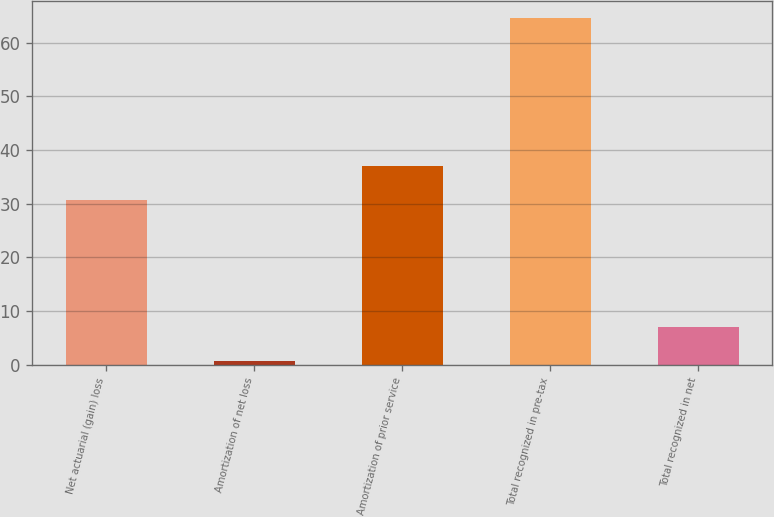<chart> <loc_0><loc_0><loc_500><loc_500><bar_chart><fcel>Net actuarial (gain) loss<fcel>Amortization of net loss<fcel>Amortization of prior service<fcel>Total recognized in pre-tax<fcel>Total recognized in net<nl><fcel>30.6<fcel>0.7<fcel>36.99<fcel>64.6<fcel>7.09<nl></chart> 